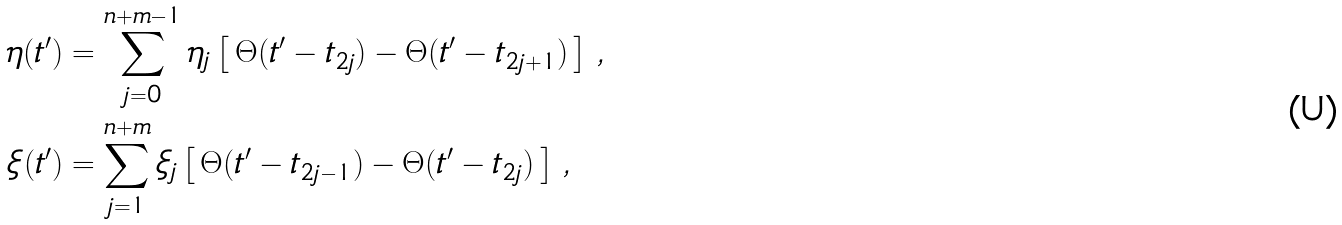<formula> <loc_0><loc_0><loc_500><loc_500>\eta ( t ^ { \prime } ) & = \sum _ { j = 0 } ^ { n + m - 1 } \eta _ { j } \left [ \, \Theta ( t ^ { \prime } - t _ { 2 j } ) - \Theta ( t ^ { \prime } - t _ { 2 j + 1 } ) \, \right ] \, , \\ \xi ( t ^ { \prime } ) & = \sum _ { j = 1 } ^ { n + m } \xi _ { j } \left [ \, \Theta ( t ^ { \prime } - t _ { 2 j - 1 } ) - \Theta ( t ^ { \prime } - t _ { 2 j } ) \, \right ] \, ,</formula> 